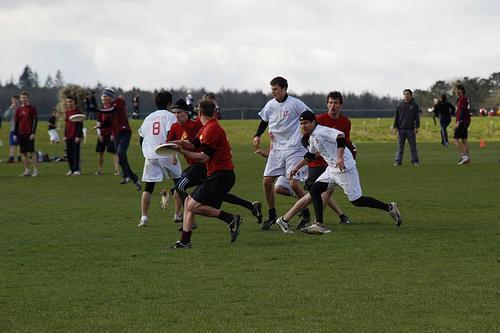How many people are wearing white shirts?
Give a very brief answer. 3. 